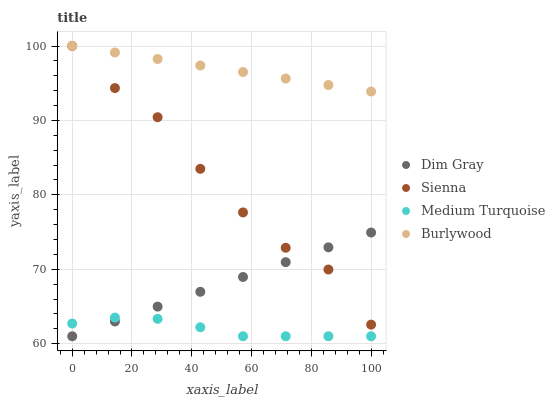Does Medium Turquoise have the minimum area under the curve?
Answer yes or no. Yes. Does Burlywood have the maximum area under the curve?
Answer yes or no. Yes. Does Dim Gray have the minimum area under the curve?
Answer yes or no. No. Does Dim Gray have the maximum area under the curve?
Answer yes or no. No. Is Dim Gray the smoothest?
Answer yes or no. Yes. Is Sienna the roughest?
Answer yes or no. Yes. Is Burlywood the smoothest?
Answer yes or no. No. Is Burlywood the roughest?
Answer yes or no. No. Does Dim Gray have the lowest value?
Answer yes or no. Yes. Does Burlywood have the lowest value?
Answer yes or no. No. Does Burlywood have the highest value?
Answer yes or no. Yes. Does Dim Gray have the highest value?
Answer yes or no. No. Is Dim Gray less than Burlywood?
Answer yes or no. Yes. Is Burlywood greater than Dim Gray?
Answer yes or no. Yes. Does Sienna intersect Burlywood?
Answer yes or no. Yes. Is Sienna less than Burlywood?
Answer yes or no. No. Is Sienna greater than Burlywood?
Answer yes or no. No. Does Dim Gray intersect Burlywood?
Answer yes or no. No. 